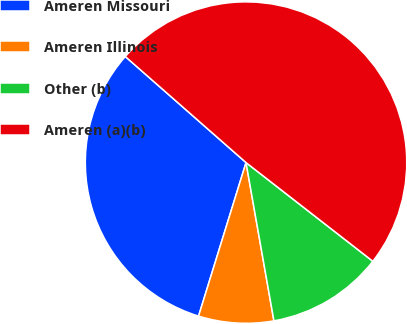Convert chart. <chart><loc_0><loc_0><loc_500><loc_500><pie_chart><fcel>Ameren Missouri<fcel>Ameren Illinois<fcel>Other (b)<fcel>Ameren (a)(b)<nl><fcel>31.7%<fcel>7.55%<fcel>11.7%<fcel>49.06%<nl></chart> 